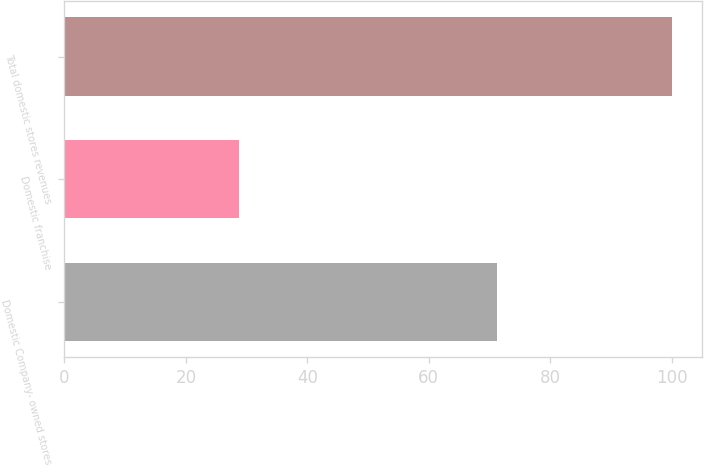Convert chart. <chart><loc_0><loc_0><loc_500><loc_500><bar_chart><fcel>Domestic Company- owned stores<fcel>Domestic franchise<fcel>Total domestic stores revenues<nl><fcel>71.2<fcel>28.8<fcel>100<nl></chart> 